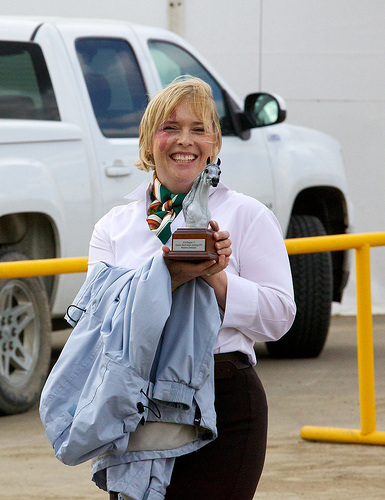<image>
Is there a person on the car? No. The person is not positioned on the car. They may be near each other, but the person is not supported by or resting on top of the car. Where is the car in relation to the women? Is it to the left of the women? No. The car is not to the left of the women. From this viewpoint, they have a different horizontal relationship. 